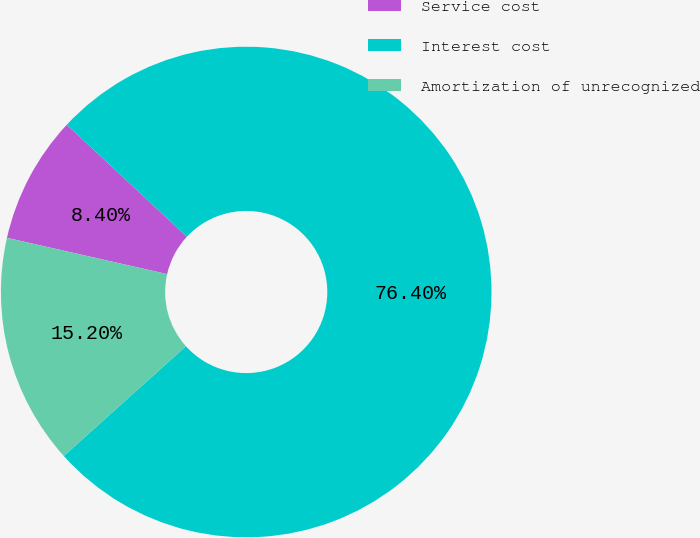Convert chart to OTSL. <chart><loc_0><loc_0><loc_500><loc_500><pie_chart><fcel>Service cost<fcel>Interest cost<fcel>Amortization of unrecognized<nl><fcel>8.4%<fcel>76.41%<fcel>15.2%<nl></chart> 